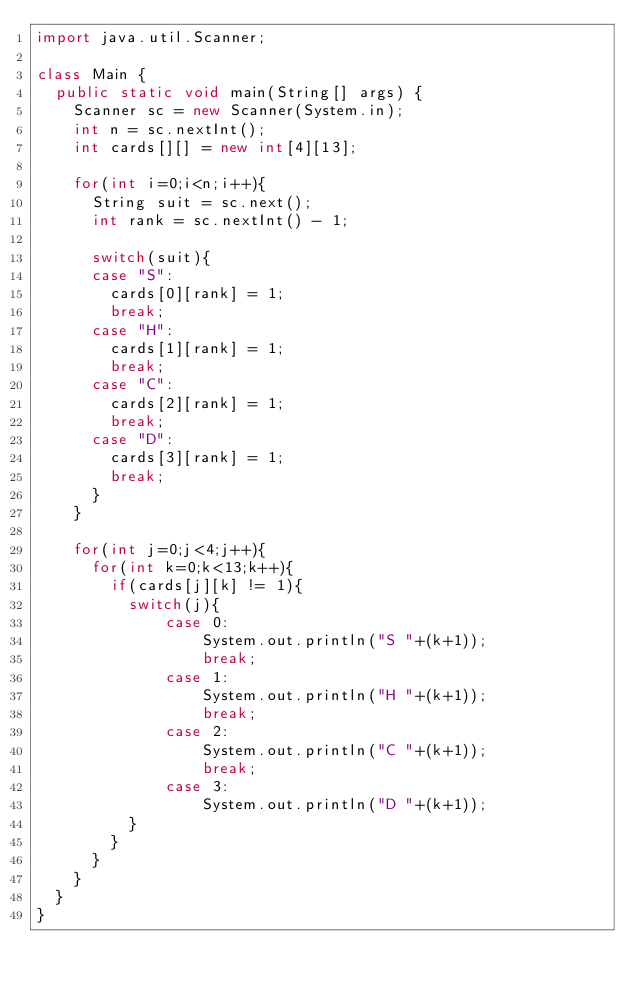Convert code to text. <code><loc_0><loc_0><loc_500><loc_500><_Java_>import java.util.Scanner;

class Main {	
	public static void main(String[] args) {
		Scanner sc = new Scanner(System.in);
		int n = sc.nextInt();
		int cards[][] = new int[4][13];
		
		for(int i=0;i<n;i++){
			String suit = sc.next();
			int rank = sc.nextInt() - 1;
			
			switch(suit){
			case "S":
				cards[0][rank] = 1;
				break;
			case "H":
				cards[1][rank] = 1;
				break;
			case "C":
				cards[2][rank] = 1;
				break;
			case "D":
				cards[3][rank] = 1;
				break;
			}
		}
		
		for(int j=0;j<4;j++){
			for(int k=0;k<13;k++){
				if(cards[j][k] != 1){
					switch(j){
					    case 0:
					        System.out.println("S "+(k+1));
					        break;
					    case 1:
					        System.out.println("H "+(k+1));
					        break;
					    case 2:
					        System.out.println("C "+(k+1));
					        break;
					    case 3:
					        System.out.println("D "+(k+1));
					}
				}
			}
		}
	}
}

</code> 